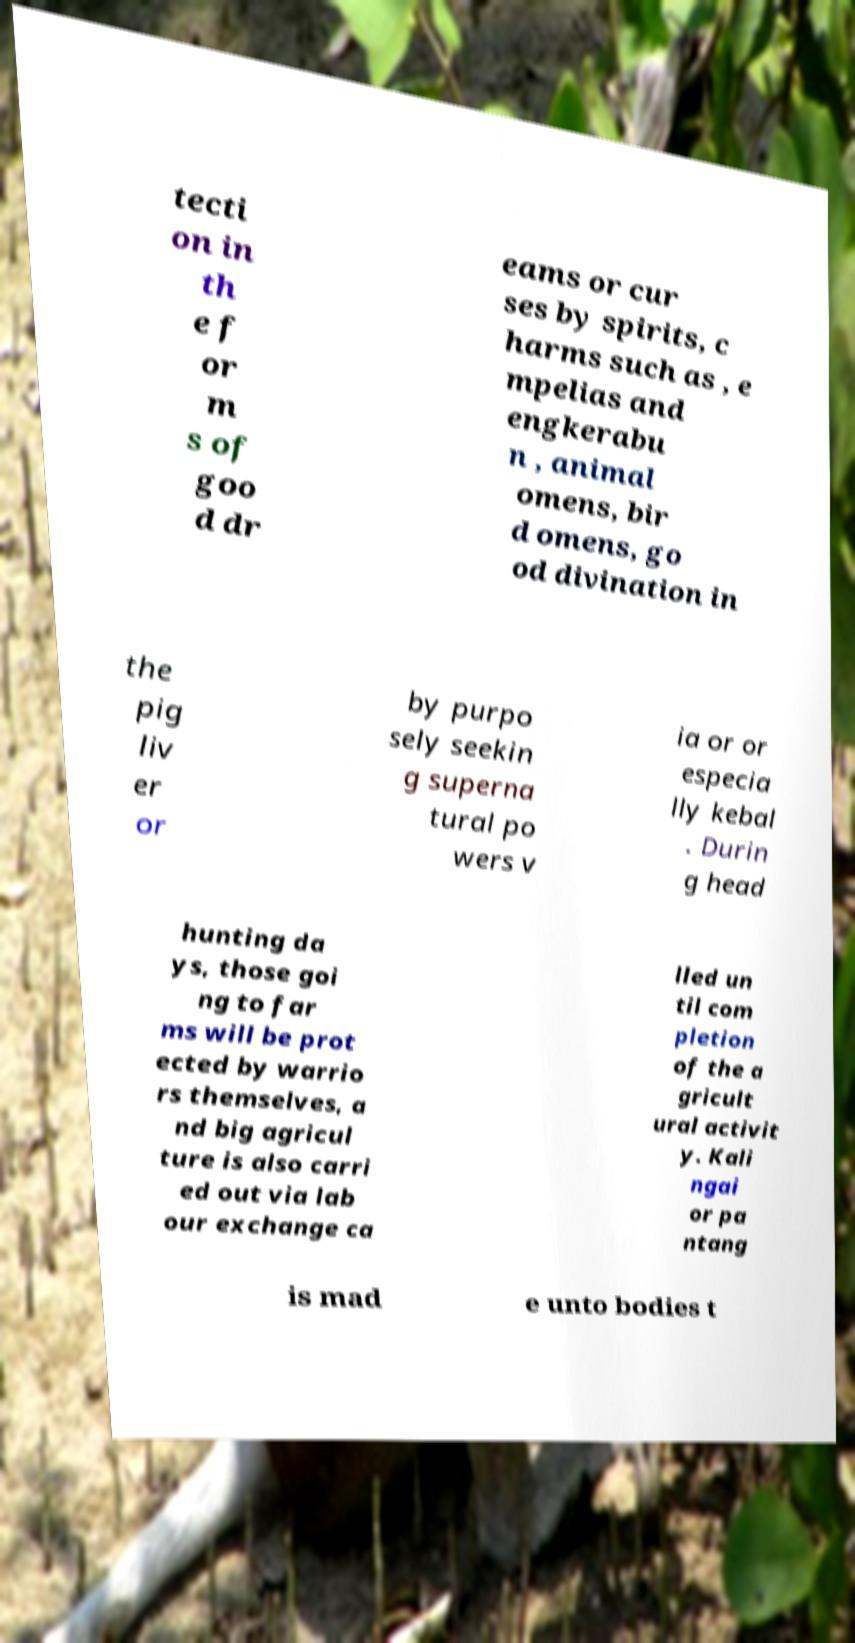For documentation purposes, I need the text within this image transcribed. Could you provide that? tecti on in th e f or m s of goo d dr eams or cur ses by spirits, c harms such as , e mpelias and engkerabu n , animal omens, bir d omens, go od divination in the pig liv er or by purpo sely seekin g superna tural po wers v ia or or especia lly kebal . Durin g head hunting da ys, those goi ng to far ms will be prot ected by warrio rs themselves, a nd big agricul ture is also carri ed out via lab our exchange ca lled un til com pletion of the a gricult ural activit y. Kali ngai or pa ntang is mad e unto bodies t 